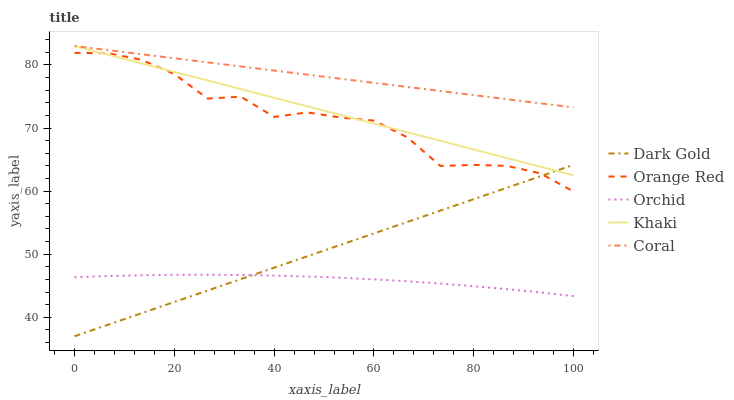Does Khaki have the minimum area under the curve?
Answer yes or no. No. Does Khaki have the maximum area under the curve?
Answer yes or no. No. Is Orchid the smoothest?
Answer yes or no. No. Is Orchid the roughest?
Answer yes or no. No. Does Orchid have the lowest value?
Answer yes or no. No. Does Orchid have the highest value?
Answer yes or no. No. Is Dark Gold less than Coral?
Answer yes or no. Yes. Is Coral greater than Dark Gold?
Answer yes or no. Yes. Does Dark Gold intersect Coral?
Answer yes or no. No. 